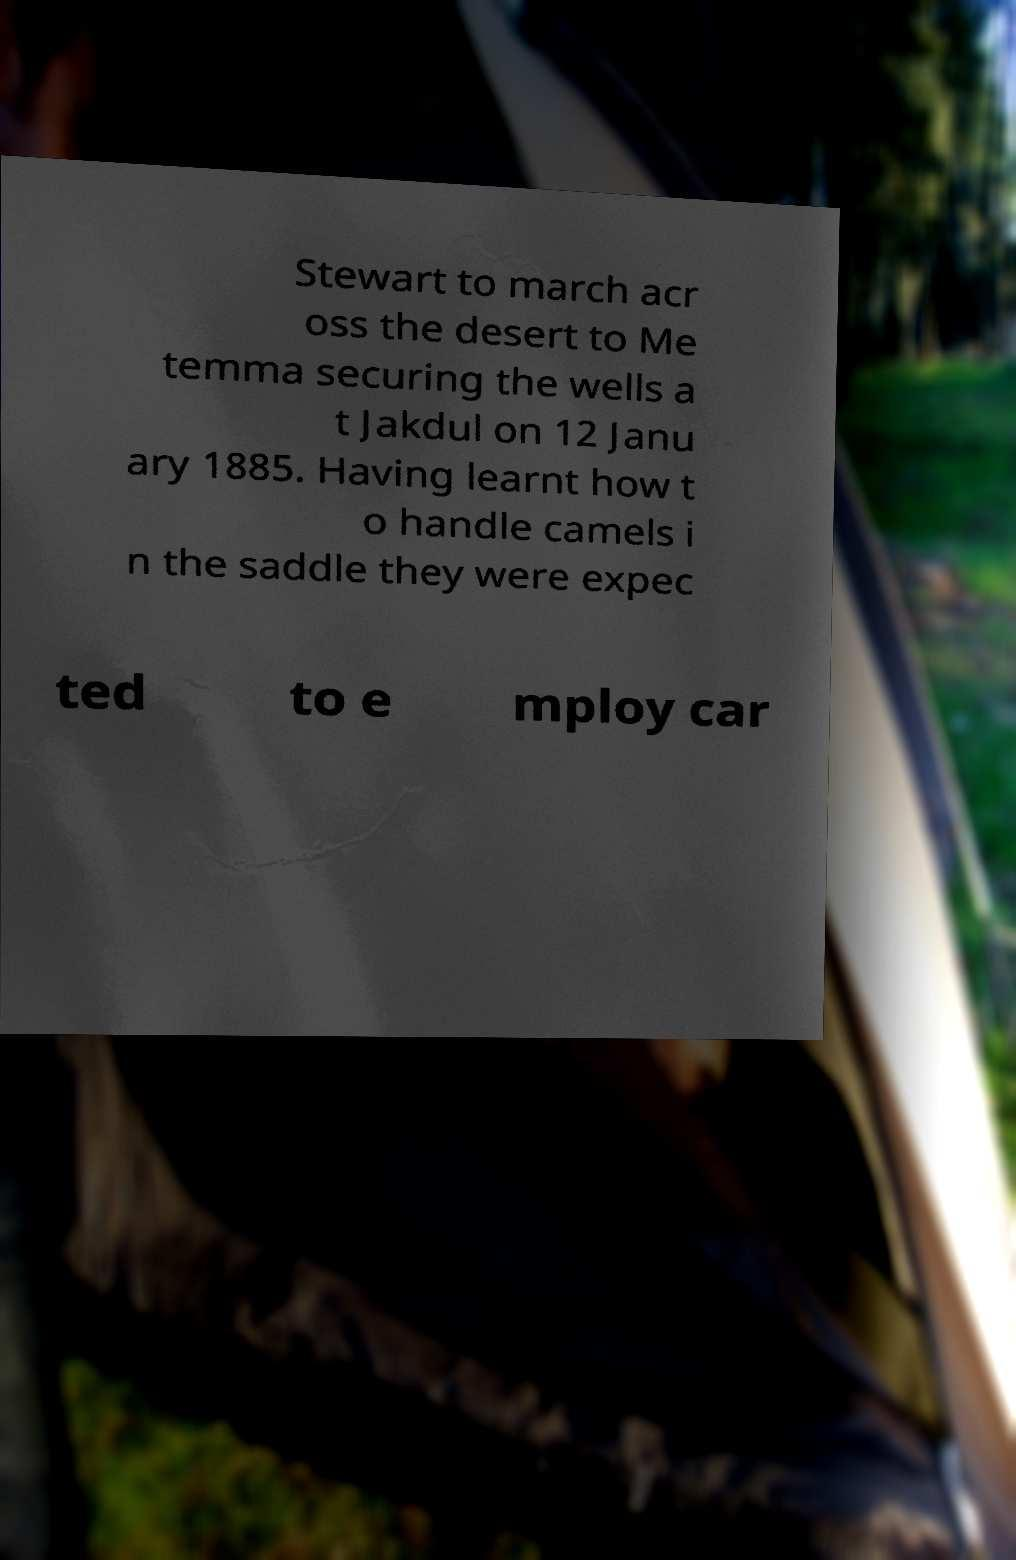For documentation purposes, I need the text within this image transcribed. Could you provide that? Stewart to march acr oss the desert to Me temma securing the wells a t Jakdul on 12 Janu ary 1885. Having learnt how t o handle camels i n the saddle they were expec ted to e mploy car 